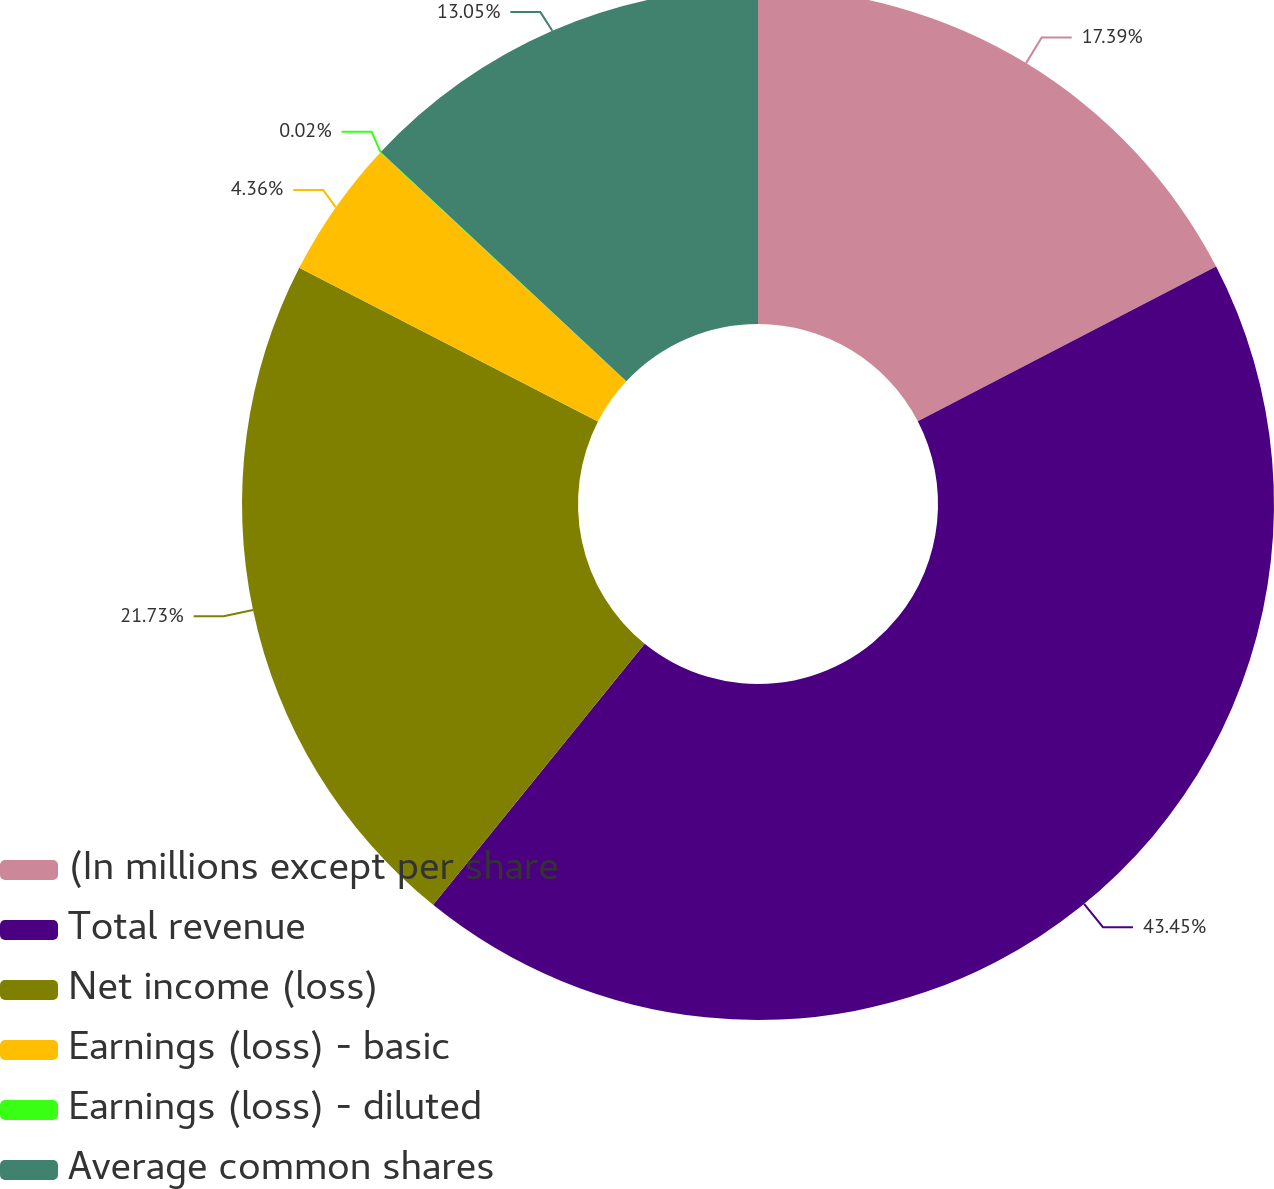Convert chart to OTSL. <chart><loc_0><loc_0><loc_500><loc_500><pie_chart><fcel>(In millions except per share<fcel>Total revenue<fcel>Net income (loss)<fcel>Earnings (loss) - basic<fcel>Earnings (loss) - diluted<fcel>Average common shares<nl><fcel>17.39%<fcel>43.45%<fcel>21.73%<fcel>4.36%<fcel>0.02%<fcel>13.05%<nl></chart> 